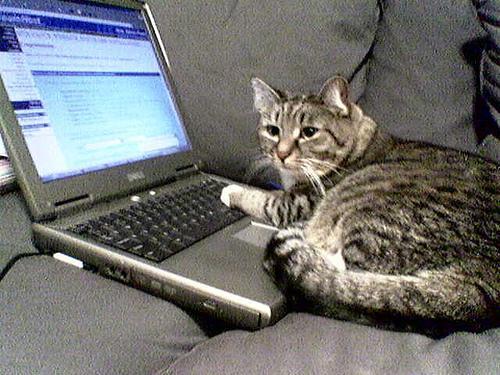How many cats are in the picture?
Give a very brief answer. 1. 